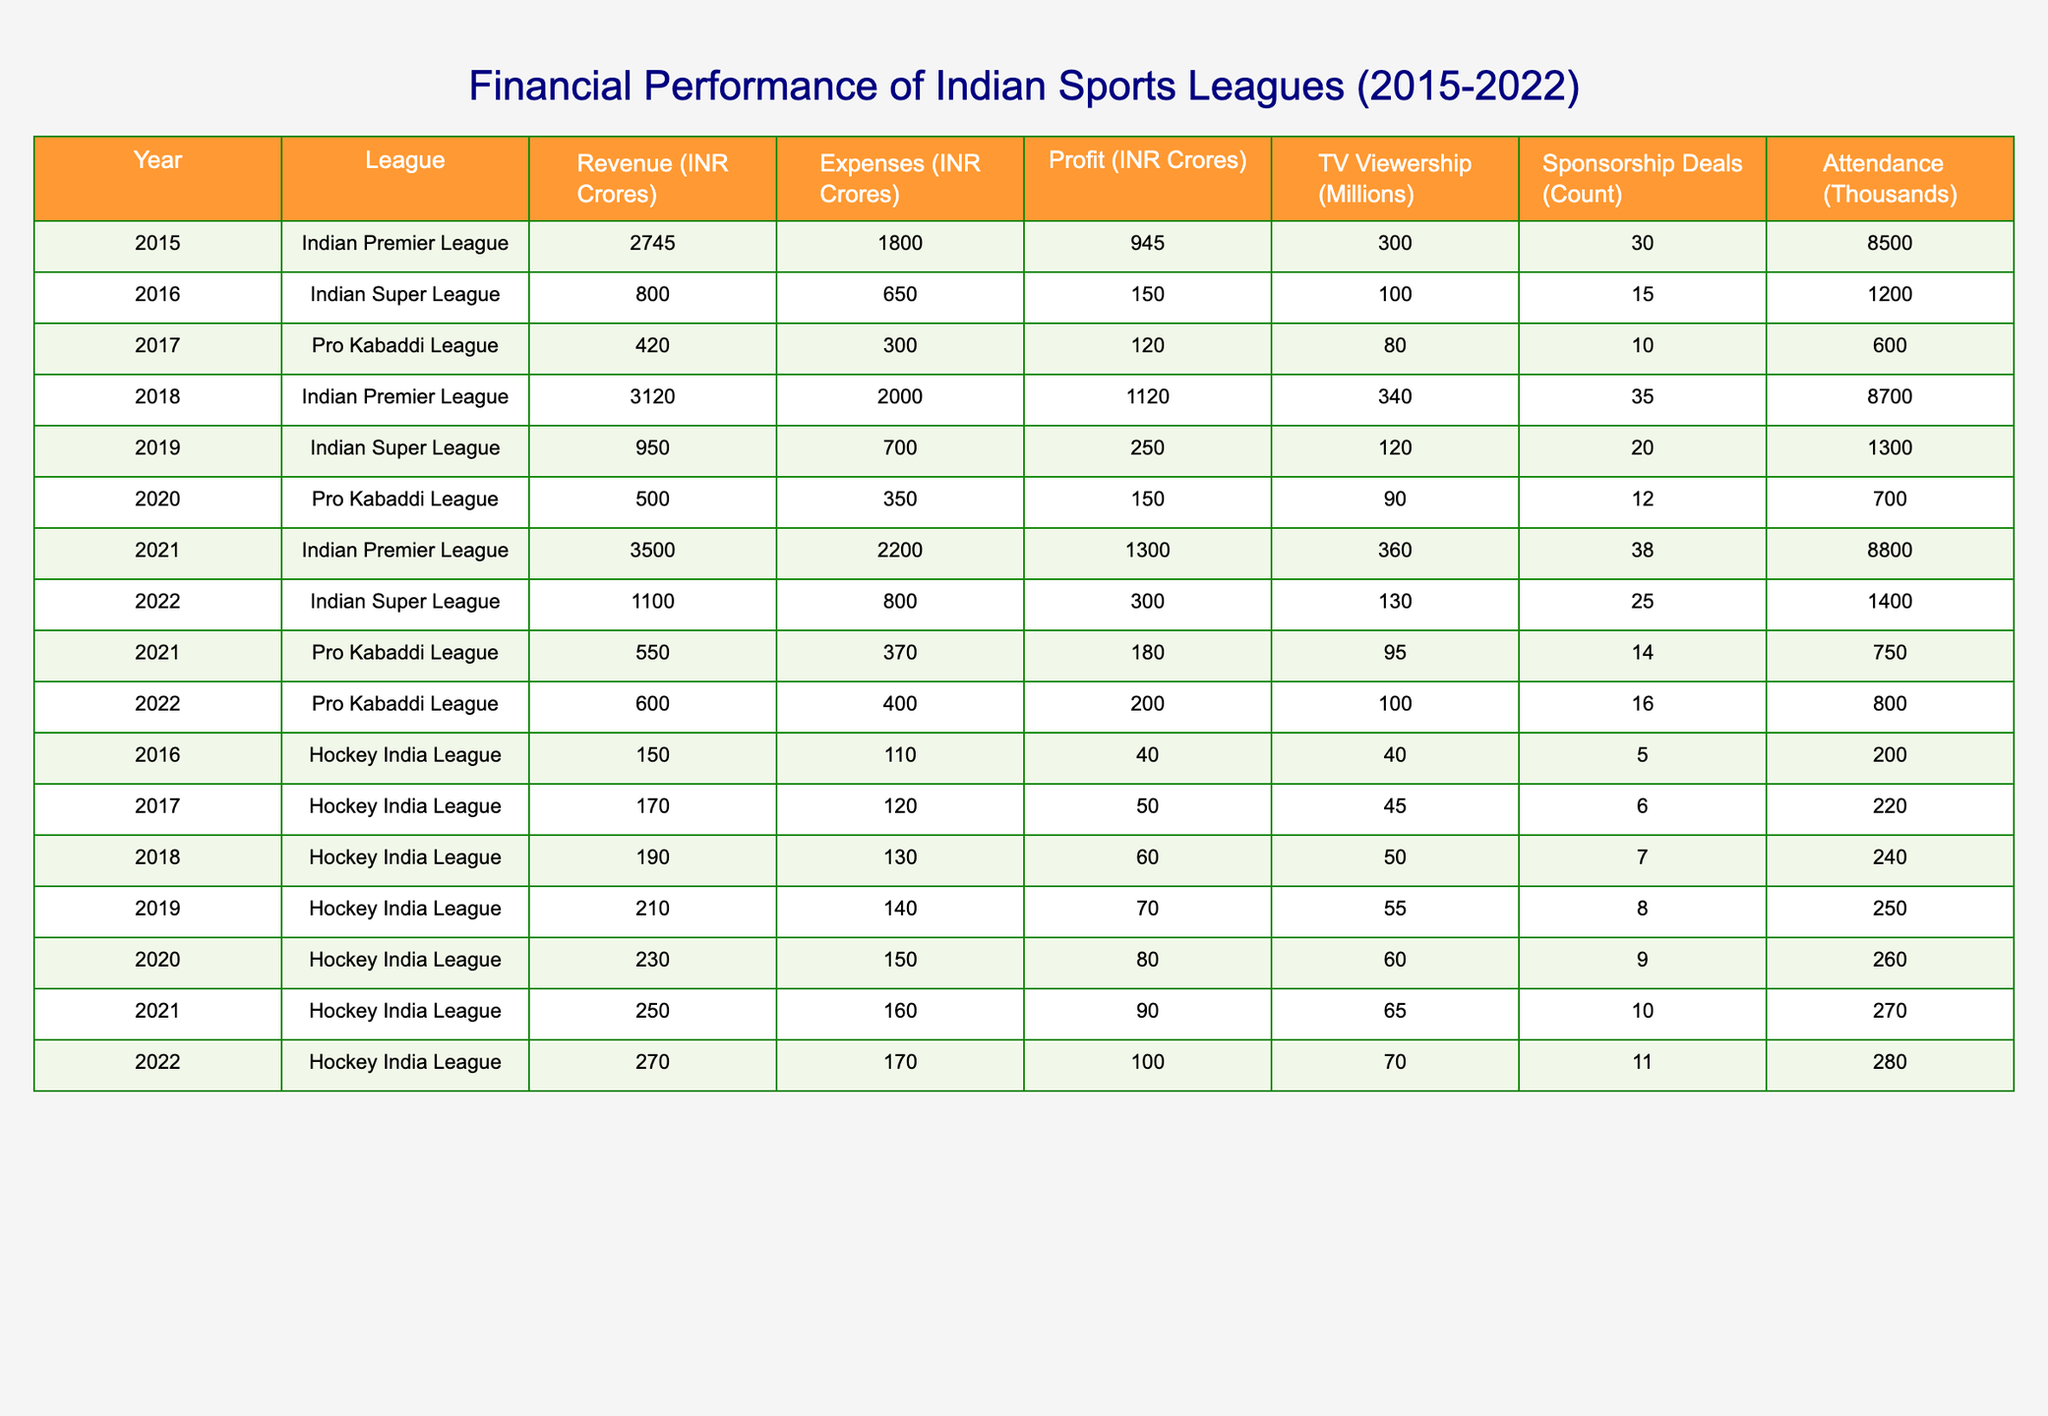What was the total revenue generated by the Indian Premier League from 2015 to 2022? To find the total revenue, we need to add the annual revenues of the Indian Premier League for each year from the table: 2745 (2015) + 3120 (2018) + 3500 (2021) = 9365. Thus, the total revenue is 9365.
Answer: 9365 In which year did the Pro Kabaddi League experience the highest profit? By examining the profit column specifically for the Pro Kabaddi League, the profits recorded were: 120 (2017), 150 (2020), 180 (2021), and 200 (2022). The highest profit was 200 in 2022.
Answer: 2022 What was the average TV viewership across all leagues during the years listed? First, we need to sum the TV viewership for all listed years and then divide by the total number of entries. The total viewership is (300 + 100 + 80 + 340 + 120 + 90 + 360 + 130 + 95 + 100 + 40 + 45 + 50 + 55 + 60 + 65 + 70) = 1880. There are 17 years total, so average viewership = 1880/17 ≈ 110.59.
Answer: 110.59 Did the expenses of the Indian Super League increase from 2019 to 2022? We need to compare the expenses in 2019, which were 700, with those in 2022, which were 800. Since 800 is greater than 700, we conclude that the expenses indeed increased.
Answer: Yes What is the percentage increase in profit for the Indian Premier League from 2015 to 2021? The profit in 2015 was 945, and in 2021 it was 1300. The increase in profit is 1300 - 945 = 355. To find the percentage increase, we use the formula (increase/original)*100 = (355/945)*100 ≈ 37.53%.
Answer: 37.53% 